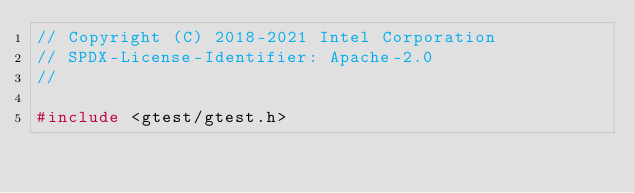<code> <loc_0><loc_0><loc_500><loc_500><_C++_>// Copyright (C) 2018-2021 Intel Corporation
// SPDX-License-Identifier: Apache-2.0
//

#include <gtest/gtest.h>
</code> 